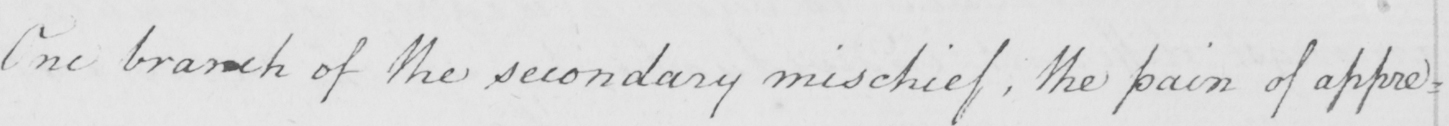Please transcribe the handwritten text in this image. One branch of the secondary mischief , the pain of appre= 